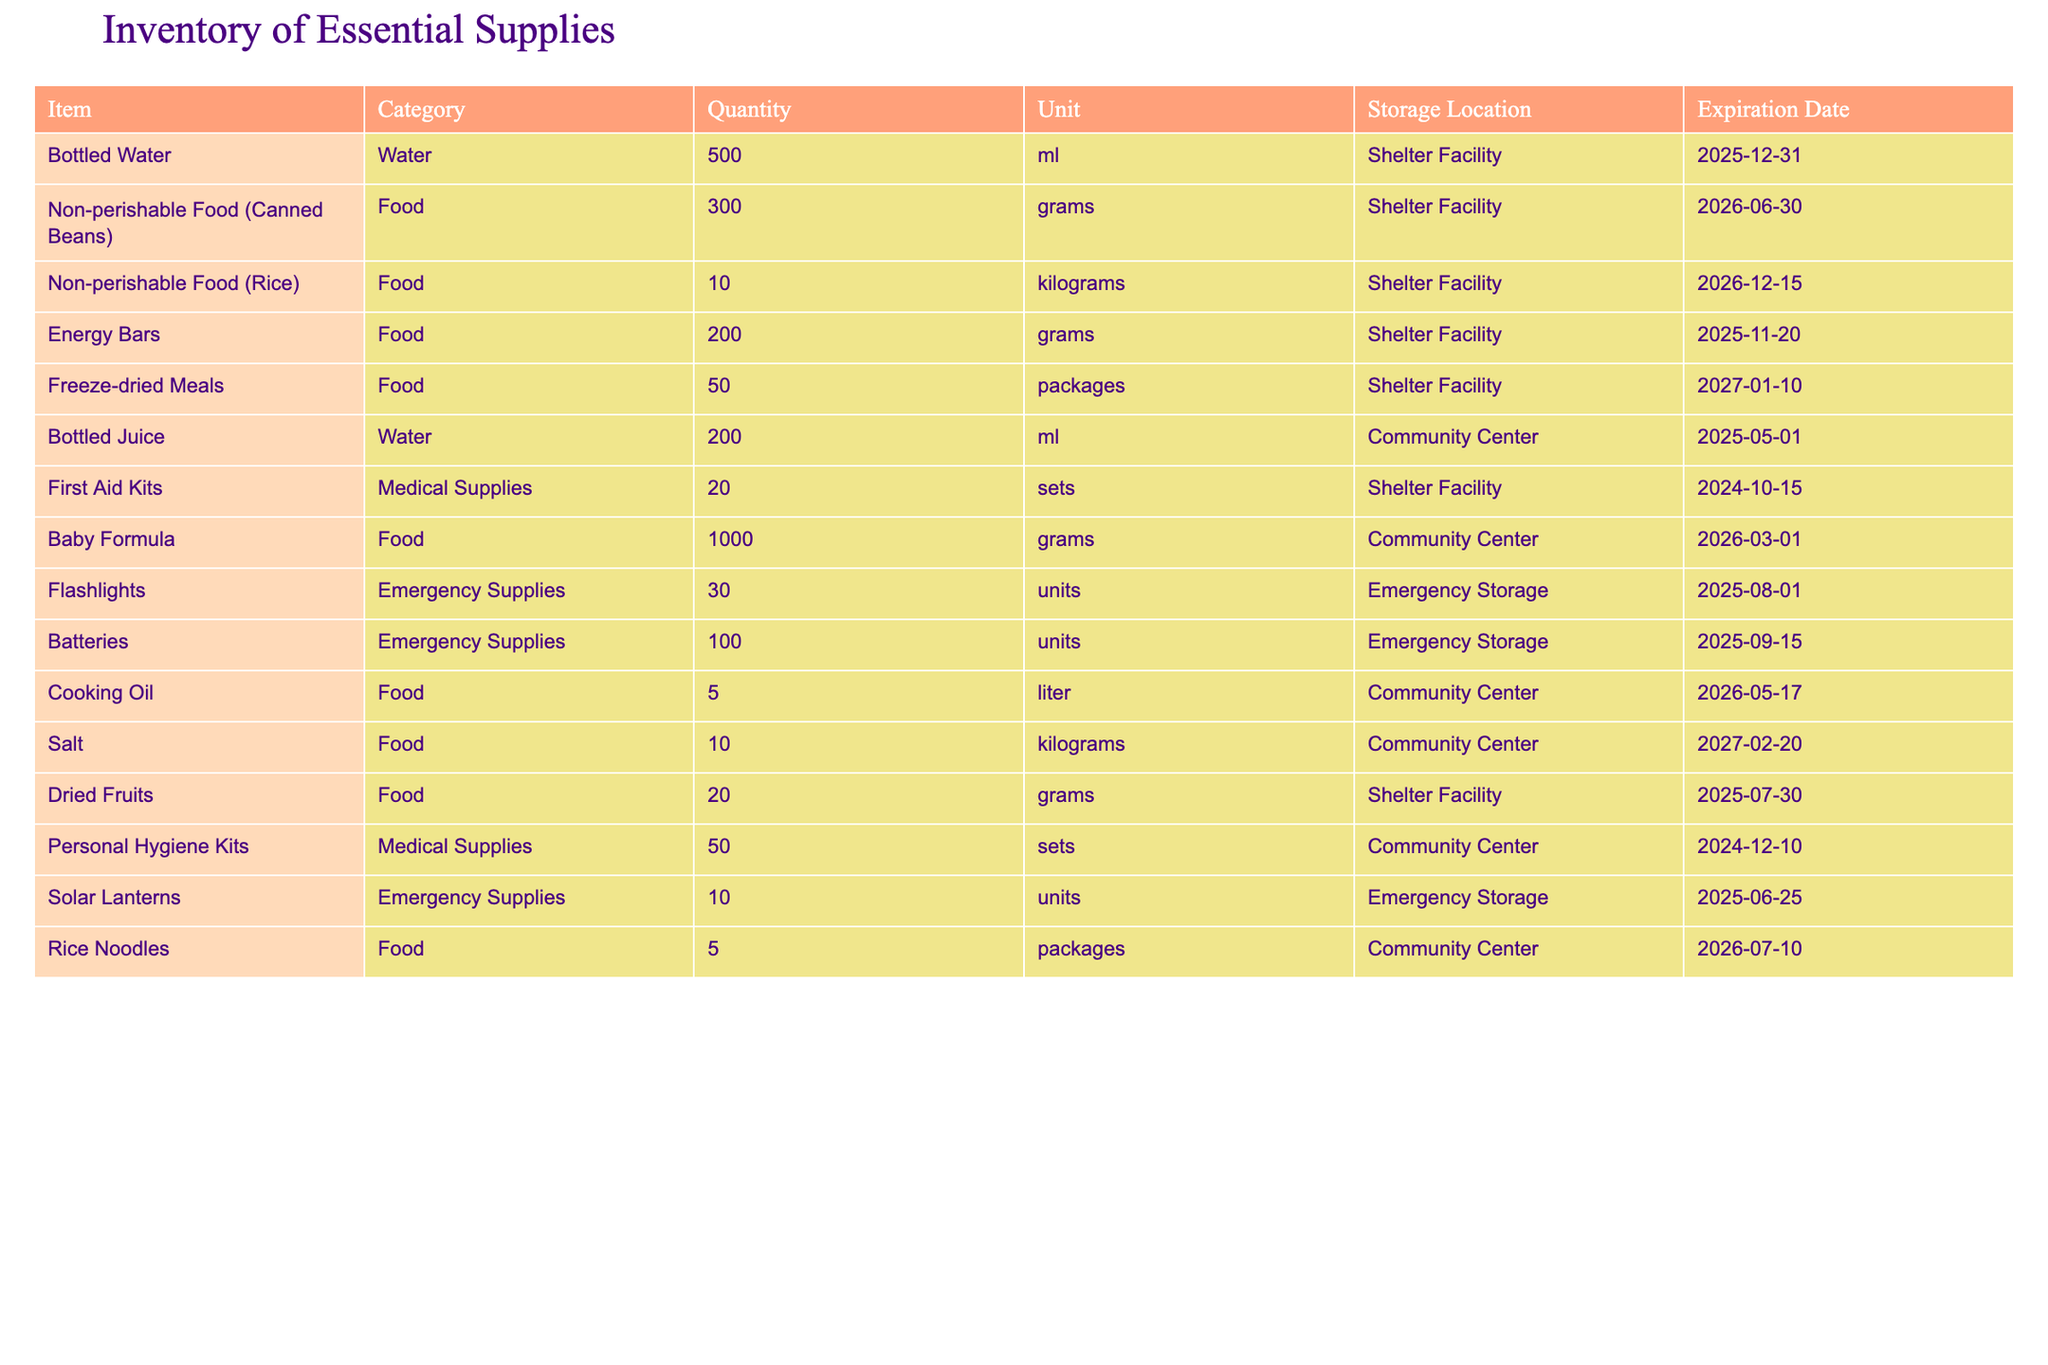What is the total quantity of bottled water available? There are 500 ml of bottled water listed in the inventory, which is directly stated in the table under the Quantity column corresponding to the Bottled Water item.
Answer: 500 ml How many different categories of supplies are listed in the inventory? The table contains three unique categories: Water, Food, and Medical Supplies, which can be counted from the Category column.
Answer: 3 What is the expiration date of the first aid kits? The expiration date for the First Aid Kits is found directly in the table under the Expiration Date column, which shows 2024-10-15.
Answer: 2024-10-15 Is there more than 1 kilogram of non-perishable food in the inventory? By checking the quantities for all non-perishable food items: Canned Beans (0.3 kg), Rice (10 kg), Energy Bars (0.2 kg), and Freeze-dried Meals (not quantified in kg), the total (0.3 + 10 + 0.2 = 10.5 kg) exceeds 1 kg, confirming there is indeed more than 1 kilogram.
Answer: Yes What is the combined quantity of food items (in grams) stored in the Community Center? The food items stored in the Community Center are Baby Formula (1000 grams), Cooking Oil (not counted in grams), and Rice Noodles (5 packages, not quantified in grams). Therefore, considering only the Baby Formula, the total in grams is 1000 grams, standing alone since Cooking Oil is measured in liters and Rice Noodles in packages. The total is therefore just the Baby Formula's quantity.
Answer: 1000 grams What is the average amount of time (in years) until the expiration of the supplies in the inventory, based on their expiration dates? To find the average time until expiration, we first calculate the years remaining for each item: for bottles of water (2 years), canned beans (2.5 years), rice (3 years), energy bars (2 years), freeze-dried meals (3.25 years), bottled juice (1.5 years), first aid kits (1 year), baby formula (2.5 years), flashlights (2 years), batteries (2 years), cooking oil (2.5 years), salt (3.25 years), dried fruits (2 years), personal hygiene kits (1.5 years), rice noodles (2.5 years). Totaling these gives 30 years, then dividing by the 15 items results in an average of 2 years until expiration.
Answer: 2 years Is there any bottled juice stored at the Shelter Facility? Checking the table reveals that Bottled Juice is stored at the Community Center, not at the Shelter Facility, therefore confirming that there is no bottled juice at the Shelter.
Answer: No How many units of emergency supplies are accounted for in total? The emergency supplies listed in the table are Flashlights (30 units), Batteries (100 units), and Solar Lanterns (10 units). Summing these values gives a total of 30 + 100 + 10 = 140 units of emergency supplies.
Answer: 140 units What is the total quantity (in liters) of cooking oil available in the inventory? The table states that there are 5 liters of Cooking Oil available at the Community Center, which can be found directly under the Quantity column for that item.
Answer: 5 liters 